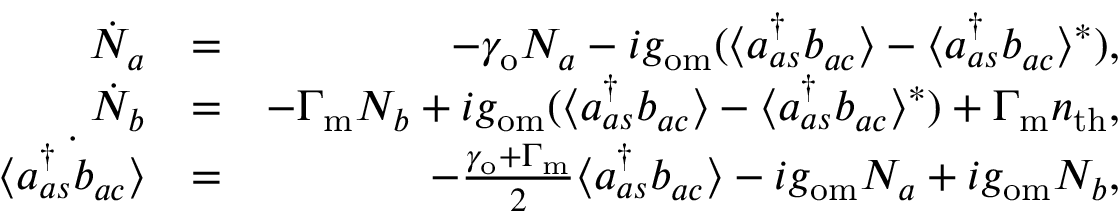<formula> <loc_0><loc_0><loc_500><loc_500>\begin{array} { r l r } { \dot { N } _ { a } } & { = } & { - \gamma _ { o } N _ { a } - i g _ { o m } ( \langle a _ { a s } ^ { \dagger } b _ { a c } \rangle - \langle a _ { a s } ^ { \dagger } b _ { a c } \rangle ^ { * } ) , } \\ { \dot { N } _ { b } } & { = } & { - \Gamma _ { m } N _ { b } + i g _ { o m } ( \langle a _ { a s } ^ { \dagger } b _ { a c } \rangle - \langle a _ { a s } ^ { \dagger } b _ { a c } \rangle ^ { * } ) + \Gamma _ { m } n _ { t h } , } \\ { \dot { \langle a _ { a s } ^ { \dagger } b _ { a c } \rangle } } & { = } & { - \frac { \gamma _ { o } + \Gamma _ { m } } { 2 } \langle a _ { a s } ^ { \dagger } b _ { a c } \rangle - i g _ { o m } N _ { a } + i g _ { o m } N _ { b } , } \end{array}</formula> 